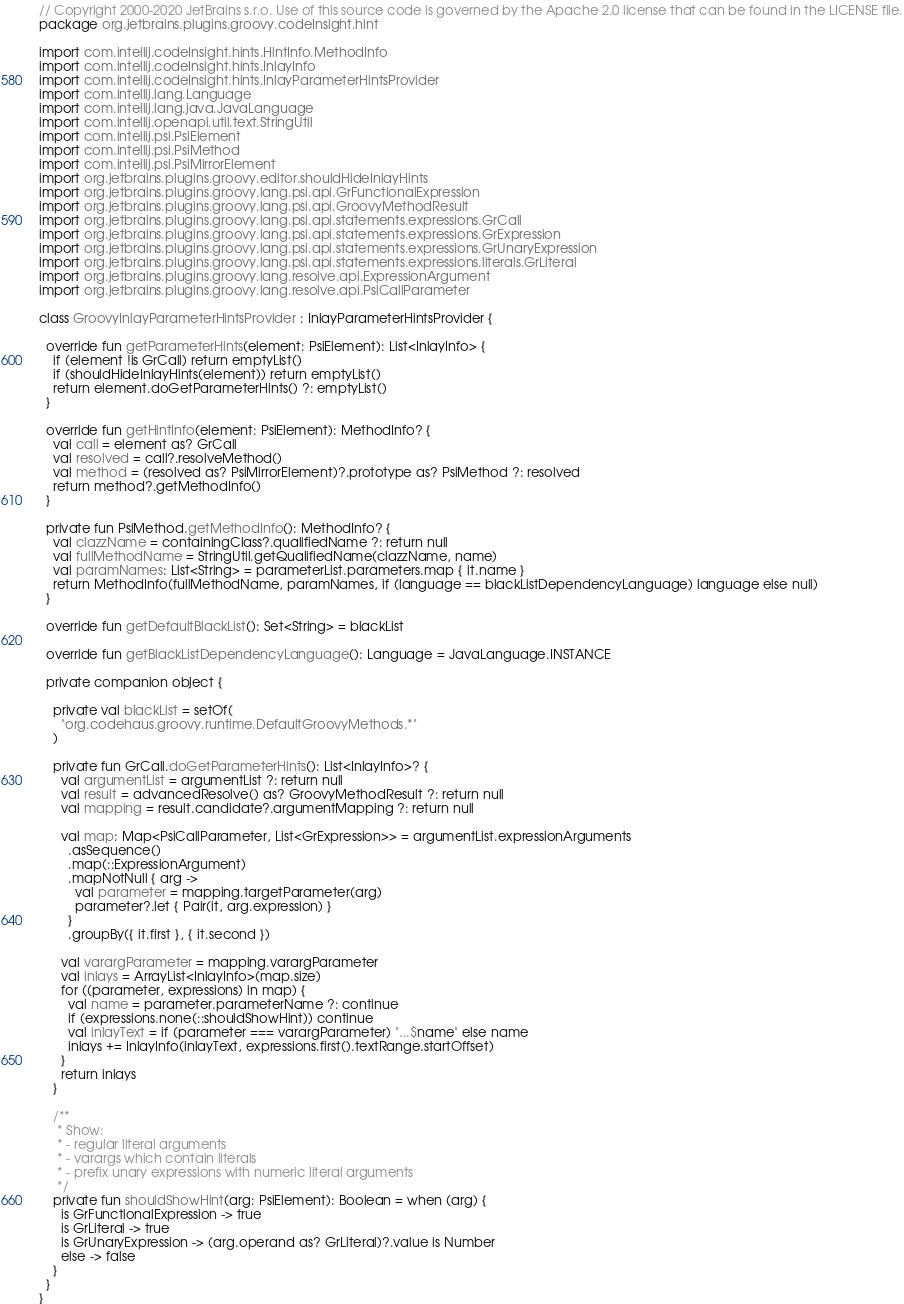<code> <loc_0><loc_0><loc_500><loc_500><_Kotlin_>// Copyright 2000-2020 JetBrains s.r.o. Use of this source code is governed by the Apache 2.0 license that can be found in the LICENSE file.
package org.jetbrains.plugins.groovy.codeInsight.hint

import com.intellij.codeInsight.hints.HintInfo.MethodInfo
import com.intellij.codeInsight.hints.InlayInfo
import com.intellij.codeInsight.hints.InlayParameterHintsProvider
import com.intellij.lang.Language
import com.intellij.lang.java.JavaLanguage
import com.intellij.openapi.util.text.StringUtil
import com.intellij.psi.PsiElement
import com.intellij.psi.PsiMethod
import com.intellij.psi.PsiMirrorElement
import org.jetbrains.plugins.groovy.editor.shouldHideInlayHints
import org.jetbrains.plugins.groovy.lang.psi.api.GrFunctionalExpression
import org.jetbrains.plugins.groovy.lang.psi.api.GroovyMethodResult
import org.jetbrains.plugins.groovy.lang.psi.api.statements.expressions.GrCall
import org.jetbrains.plugins.groovy.lang.psi.api.statements.expressions.GrExpression
import org.jetbrains.plugins.groovy.lang.psi.api.statements.expressions.GrUnaryExpression
import org.jetbrains.plugins.groovy.lang.psi.api.statements.expressions.literals.GrLiteral
import org.jetbrains.plugins.groovy.lang.resolve.api.ExpressionArgument
import org.jetbrains.plugins.groovy.lang.resolve.api.PsiCallParameter

class GroovyInlayParameterHintsProvider : InlayParameterHintsProvider {

  override fun getParameterHints(element: PsiElement): List<InlayInfo> {
    if (element !is GrCall) return emptyList()
    if (shouldHideInlayHints(element)) return emptyList()
    return element.doGetParameterHints() ?: emptyList()
  }

  override fun getHintInfo(element: PsiElement): MethodInfo? {
    val call = element as? GrCall
    val resolved = call?.resolveMethod()
    val method = (resolved as? PsiMirrorElement)?.prototype as? PsiMethod ?: resolved
    return method?.getMethodInfo()
  }

  private fun PsiMethod.getMethodInfo(): MethodInfo? {
    val clazzName = containingClass?.qualifiedName ?: return null
    val fullMethodName = StringUtil.getQualifiedName(clazzName, name)
    val paramNames: List<String> = parameterList.parameters.map { it.name }
    return MethodInfo(fullMethodName, paramNames, if (language == blackListDependencyLanguage) language else null)
  }

  override fun getDefaultBlackList(): Set<String> = blackList

  override fun getBlackListDependencyLanguage(): Language = JavaLanguage.INSTANCE

  private companion object {

    private val blackList = setOf(
      "org.codehaus.groovy.runtime.DefaultGroovyMethods.*"
    )

    private fun GrCall.doGetParameterHints(): List<InlayInfo>? {
      val argumentList = argumentList ?: return null
      val result = advancedResolve() as? GroovyMethodResult ?: return null
      val mapping = result.candidate?.argumentMapping ?: return null

      val map: Map<PsiCallParameter, List<GrExpression>> = argumentList.expressionArguments
        .asSequence()
        .map(::ExpressionArgument)
        .mapNotNull { arg ->
          val parameter = mapping.targetParameter(arg)
          parameter?.let { Pair(it, arg.expression) }
        }
        .groupBy({ it.first }, { it.second })

      val varargParameter = mapping.varargParameter
      val inlays = ArrayList<InlayInfo>(map.size)
      for ((parameter, expressions) in map) {
        val name = parameter.parameterName ?: continue
        if (expressions.none(::shouldShowHint)) continue
        val inlayText = if (parameter === varargParameter) "...$name" else name
        inlays += InlayInfo(inlayText, expressions.first().textRange.startOffset)
      }
      return inlays
    }

    /**
     * Show:
     * - regular literal arguments
     * - varargs which contain literals
     * - prefix unary expressions with numeric literal arguments
     */
    private fun shouldShowHint(arg: PsiElement): Boolean = when (arg) {
      is GrFunctionalExpression -> true
      is GrLiteral -> true
      is GrUnaryExpression -> (arg.operand as? GrLiteral)?.value is Number
      else -> false
    }
  }
}
</code> 